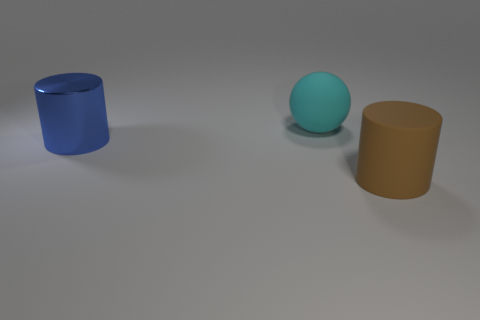There is a rubber thing that is in front of the sphere; is its size the same as the large blue thing?
Your answer should be compact. Yes. What is the large brown thing made of?
Make the answer very short. Rubber. The big rubber thing left of the large matte cylinder is what color?
Give a very brief answer. Cyan. What number of big things are shiny things or red metallic cubes?
Your answer should be compact. 1. There is a large rubber object right of the cyan ball; is its color the same as the large thing that is behind the blue metallic cylinder?
Offer a terse response. No. What number of cyan objects are large matte balls or tiny metallic cylinders?
Your response must be concise. 1. Does the cyan matte thing have the same shape as the rubber object in front of the blue object?
Your answer should be very brief. No. The big blue object has what shape?
Your answer should be compact. Cylinder. There is a blue cylinder that is the same size as the cyan object; what material is it?
Keep it short and to the point. Metal. Is there any other thing that has the same size as the rubber sphere?
Provide a short and direct response. Yes. 